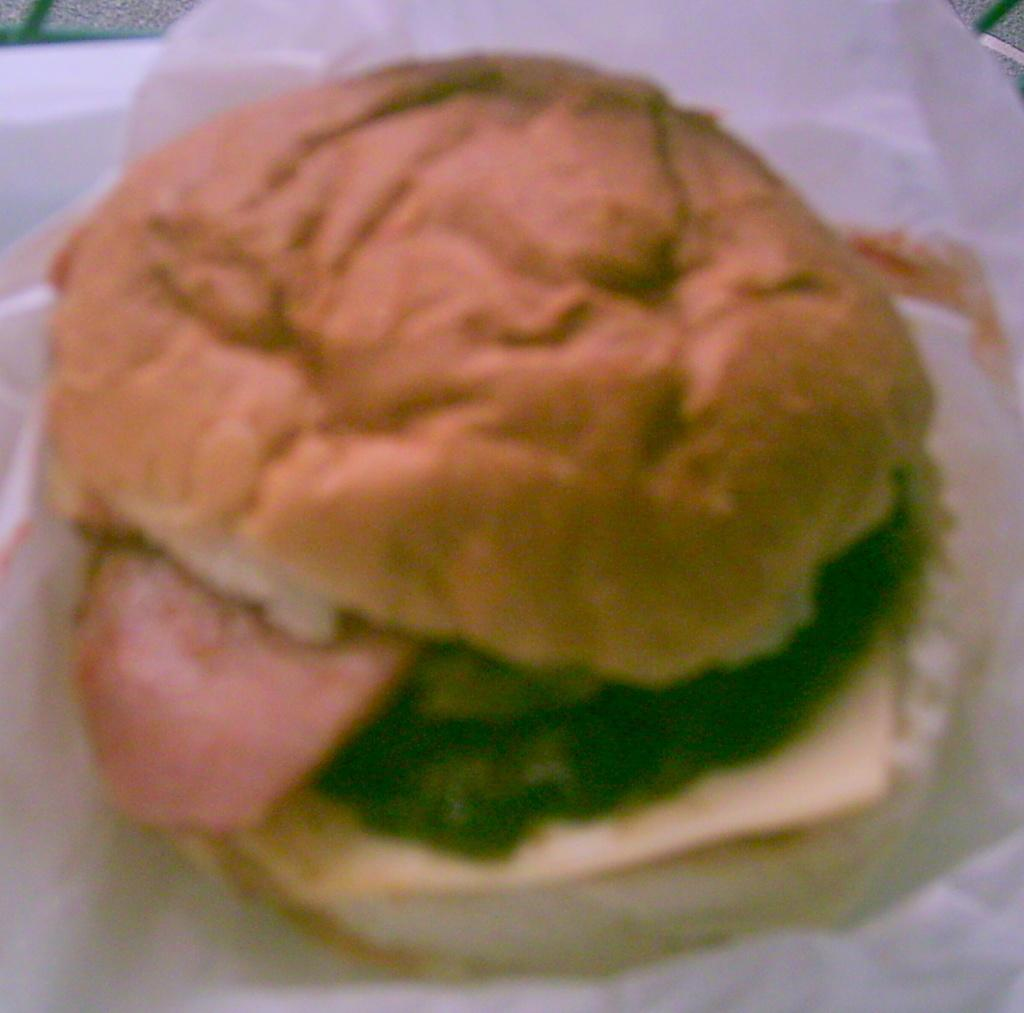What type of food is shown in the image? There is a burger in the image. How is the burger wrapped or packaged? The burger is packed in white paper. What is the burger placed on? The burger is placed on a plate. What type of baseball is visible in the image? There is no baseball present in the image; it features a burger packed in white paper and placed on a plate. 